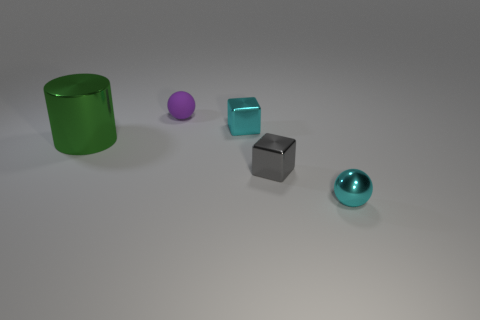Add 4 big shiny blocks. How many objects exist? 9 Subtract all cubes. How many objects are left? 3 Subtract 2 cubes. How many cubes are left? 0 Subtract 0 purple blocks. How many objects are left? 5 Subtract all purple spheres. Subtract all brown blocks. How many spheres are left? 1 Subtract all yellow blocks. How many purple spheres are left? 1 Subtract all tiny blocks. Subtract all red objects. How many objects are left? 3 Add 2 tiny spheres. How many tiny spheres are left? 4 Add 2 tiny gray blocks. How many tiny gray blocks exist? 3 Subtract all cyan spheres. How many spheres are left? 1 